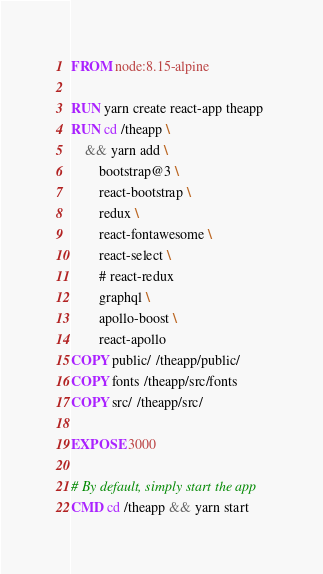<code> <loc_0><loc_0><loc_500><loc_500><_Dockerfile_>FROM node:8.15-alpine

RUN yarn create react-app theapp 
RUN cd /theapp \
	&& yarn add \		
		bootstrap@3 \
		react-bootstrap \
		redux \
		react-fontawesome \
		react-select \
		# react-redux
		graphql \
		apollo-boost \
		react-apollo
COPY public/ /theapp/public/
COPY fonts /theapp/src/fonts
COPY src/ /theapp/src/
		
EXPOSE 3000

# By default, simply start the app
CMD cd /theapp && yarn start
</code> 